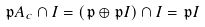<formula> <loc_0><loc_0><loc_500><loc_500>\mathfrak { p } A _ { c } \cap I = ( \mathfrak { p } \oplus \mathfrak { p } I ) \cap I = \mathfrak { p } I</formula> 